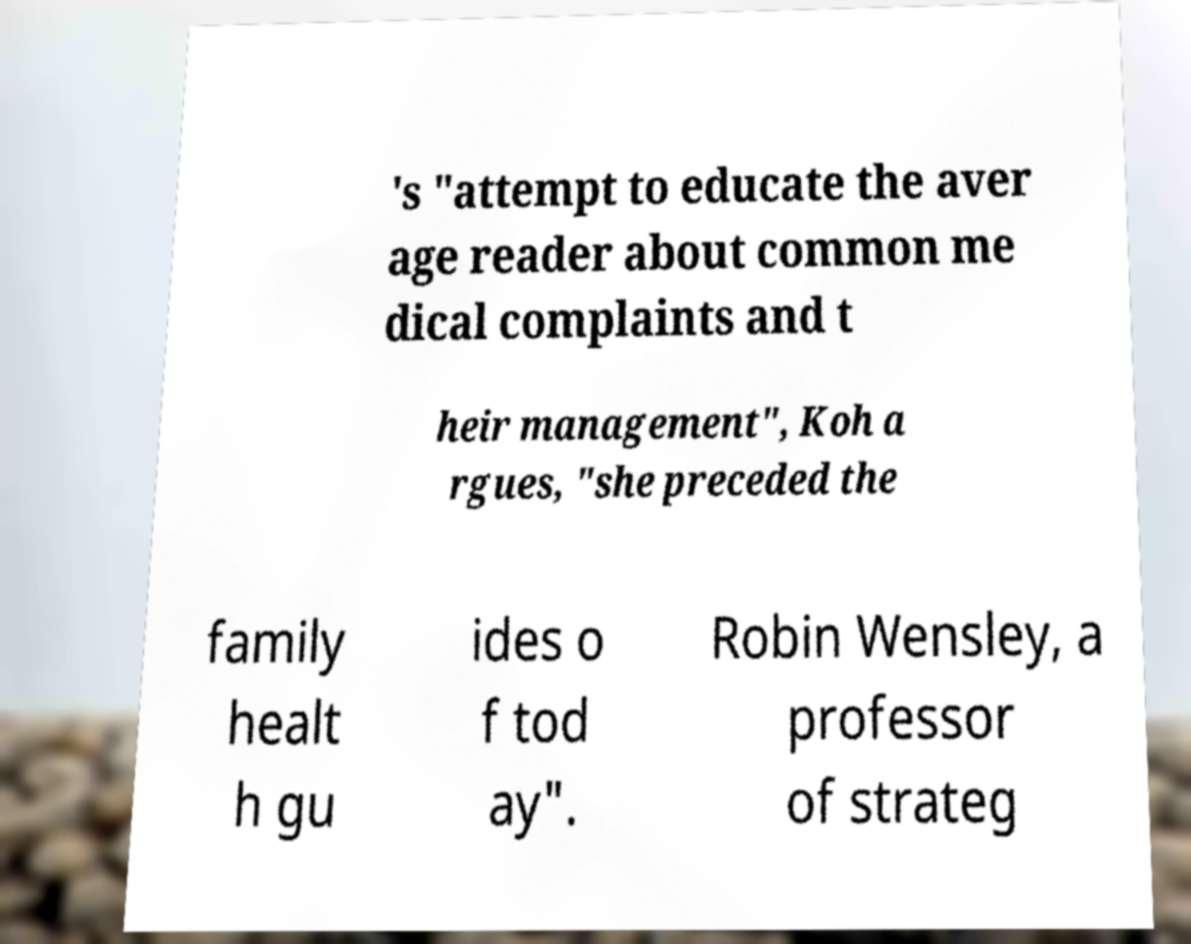Please identify and transcribe the text found in this image. 's "attempt to educate the aver age reader about common me dical complaints and t heir management", Koh a rgues, "she preceded the family healt h gu ides o f tod ay". Robin Wensley, a professor of strateg 